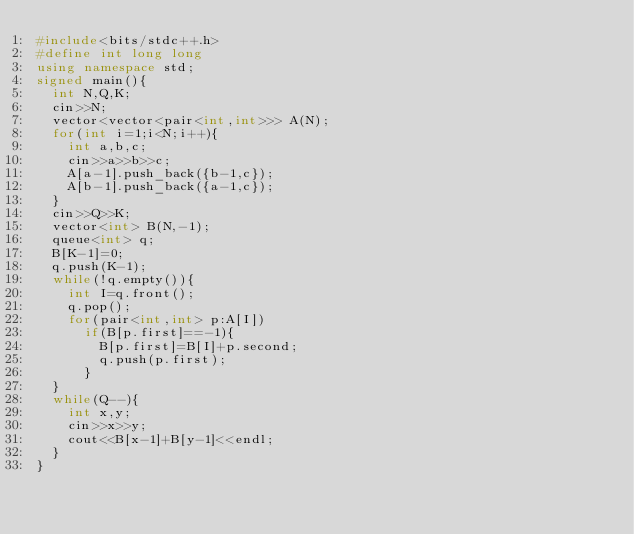<code> <loc_0><loc_0><loc_500><loc_500><_C++_>#include<bits/stdc++.h>
#define int long long
using namespace std;
signed main(){
  int N,Q,K;
  cin>>N;
  vector<vector<pair<int,int>>> A(N);
  for(int i=1;i<N;i++){
    int a,b,c;
    cin>>a>>b>>c;
    A[a-1].push_back({b-1,c});
    A[b-1].push_back({a-1,c});
  }
  cin>>Q>>K;
  vector<int> B(N,-1);
  queue<int> q;
  B[K-1]=0;
  q.push(K-1);
  while(!q.empty()){
    int I=q.front();
    q.pop();
    for(pair<int,int> p:A[I])
      if(B[p.first]==-1){
        B[p.first]=B[I]+p.second;
        q.push(p.first);
      }
  }
  while(Q--){
    int x,y;
    cin>>x>>y;
    cout<<B[x-1]+B[y-1]<<endl;
  }
}</code> 